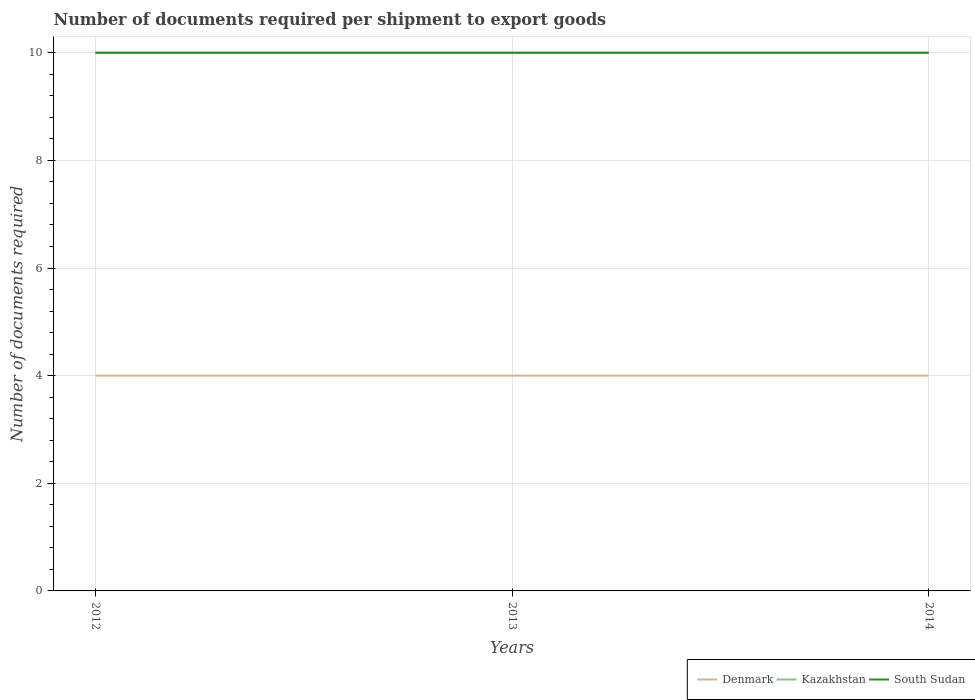Across all years, what is the maximum number of documents required per shipment to export goods in Denmark?
Your answer should be compact. 4. In which year was the number of documents required per shipment to export goods in Denmark maximum?
Offer a very short reply. 2012. What is the difference between the highest and the lowest number of documents required per shipment to export goods in South Sudan?
Give a very brief answer. 0. How many lines are there?
Ensure brevity in your answer.  3. Are the values on the major ticks of Y-axis written in scientific E-notation?
Your answer should be very brief. No. Where does the legend appear in the graph?
Offer a terse response. Bottom right. How are the legend labels stacked?
Ensure brevity in your answer.  Horizontal. What is the title of the graph?
Provide a succinct answer. Number of documents required per shipment to export goods. What is the label or title of the Y-axis?
Keep it short and to the point. Number of documents required. What is the Number of documents required of Denmark in 2012?
Your answer should be very brief. 4. What is the Number of documents required in Kazakhstan in 2012?
Your response must be concise. 10. What is the Number of documents required of Denmark in 2013?
Provide a short and direct response. 4. What is the Number of documents required in Kazakhstan in 2013?
Your answer should be very brief. 10. What is the Number of documents required in Kazakhstan in 2014?
Your answer should be compact. 10. What is the Number of documents required of South Sudan in 2014?
Make the answer very short. 10. Across all years, what is the minimum Number of documents required in Denmark?
Ensure brevity in your answer.  4. Across all years, what is the minimum Number of documents required of Kazakhstan?
Your answer should be very brief. 10. Across all years, what is the minimum Number of documents required in South Sudan?
Your answer should be very brief. 10. What is the total Number of documents required of Denmark in the graph?
Provide a succinct answer. 12. What is the total Number of documents required of South Sudan in the graph?
Give a very brief answer. 30. What is the difference between the Number of documents required in Denmark in 2012 and that in 2013?
Give a very brief answer. 0. What is the difference between the Number of documents required of Kazakhstan in 2012 and that in 2013?
Offer a terse response. 0. What is the difference between the Number of documents required of South Sudan in 2012 and that in 2013?
Offer a terse response. 0. What is the difference between the Number of documents required of South Sudan in 2012 and that in 2014?
Offer a very short reply. 0. What is the difference between the Number of documents required of Denmark in 2013 and that in 2014?
Your response must be concise. 0. What is the difference between the Number of documents required of South Sudan in 2013 and that in 2014?
Give a very brief answer. 0. What is the difference between the Number of documents required in Denmark in 2012 and the Number of documents required in Kazakhstan in 2013?
Provide a succinct answer. -6. What is the difference between the Number of documents required in Denmark in 2012 and the Number of documents required in South Sudan in 2013?
Keep it short and to the point. -6. What is the difference between the Number of documents required of Kazakhstan in 2012 and the Number of documents required of South Sudan in 2013?
Ensure brevity in your answer.  0. What is the difference between the Number of documents required of Denmark in 2012 and the Number of documents required of Kazakhstan in 2014?
Offer a very short reply. -6. What is the difference between the Number of documents required in Denmark in 2013 and the Number of documents required in Kazakhstan in 2014?
Ensure brevity in your answer.  -6. What is the difference between the Number of documents required of Denmark in 2013 and the Number of documents required of South Sudan in 2014?
Offer a terse response. -6. What is the difference between the Number of documents required in Kazakhstan in 2013 and the Number of documents required in South Sudan in 2014?
Provide a succinct answer. 0. What is the average Number of documents required of Kazakhstan per year?
Your response must be concise. 10. In the year 2012, what is the difference between the Number of documents required in Denmark and Number of documents required in South Sudan?
Ensure brevity in your answer.  -6. In the year 2012, what is the difference between the Number of documents required in Kazakhstan and Number of documents required in South Sudan?
Your answer should be compact. 0. In the year 2013, what is the difference between the Number of documents required in Kazakhstan and Number of documents required in South Sudan?
Offer a terse response. 0. In the year 2014, what is the difference between the Number of documents required in Denmark and Number of documents required in Kazakhstan?
Ensure brevity in your answer.  -6. In the year 2014, what is the difference between the Number of documents required of Kazakhstan and Number of documents required of South Sudan?
Give a very brief answer. 0. What is the ratio of the Number of documents required of Denmark in 2012 to that in 2013?
Offer a terse response. 1. What is the ratio of the Number of documents required of Kazakhstan in 2012 to that in 2013?
Your answer should be very brief. 1. What is the ratio of the Number of documents required in South Sudan in 2012 to that in 2013?
Your response must be concise. 1. What is the ratio of the Number of documents required in Denmark in 2012 to that in 2014?
Your answer should be very brief. 1. What is the ratio of the Number of documents required in South Sudan in 2012 to that in 2014?
Provide a succinct answer. 1. What is the ratio of the Number of documents required of Kazakhstan in 2013 to that in 2014?
Your answer should be very brief. 1. What is the ratio of the Number of documents required in South Sudan in 2013 to that in 2014?
Your response must be concise. 1. What is the difference between the highest and the second highest Number of documents required in Kazakhstan?
Ensure brevity in your answer.  0. What is the difference between the highest and the lowest Number of documents required in Denmark?
Provide a succinct answer. 0. 